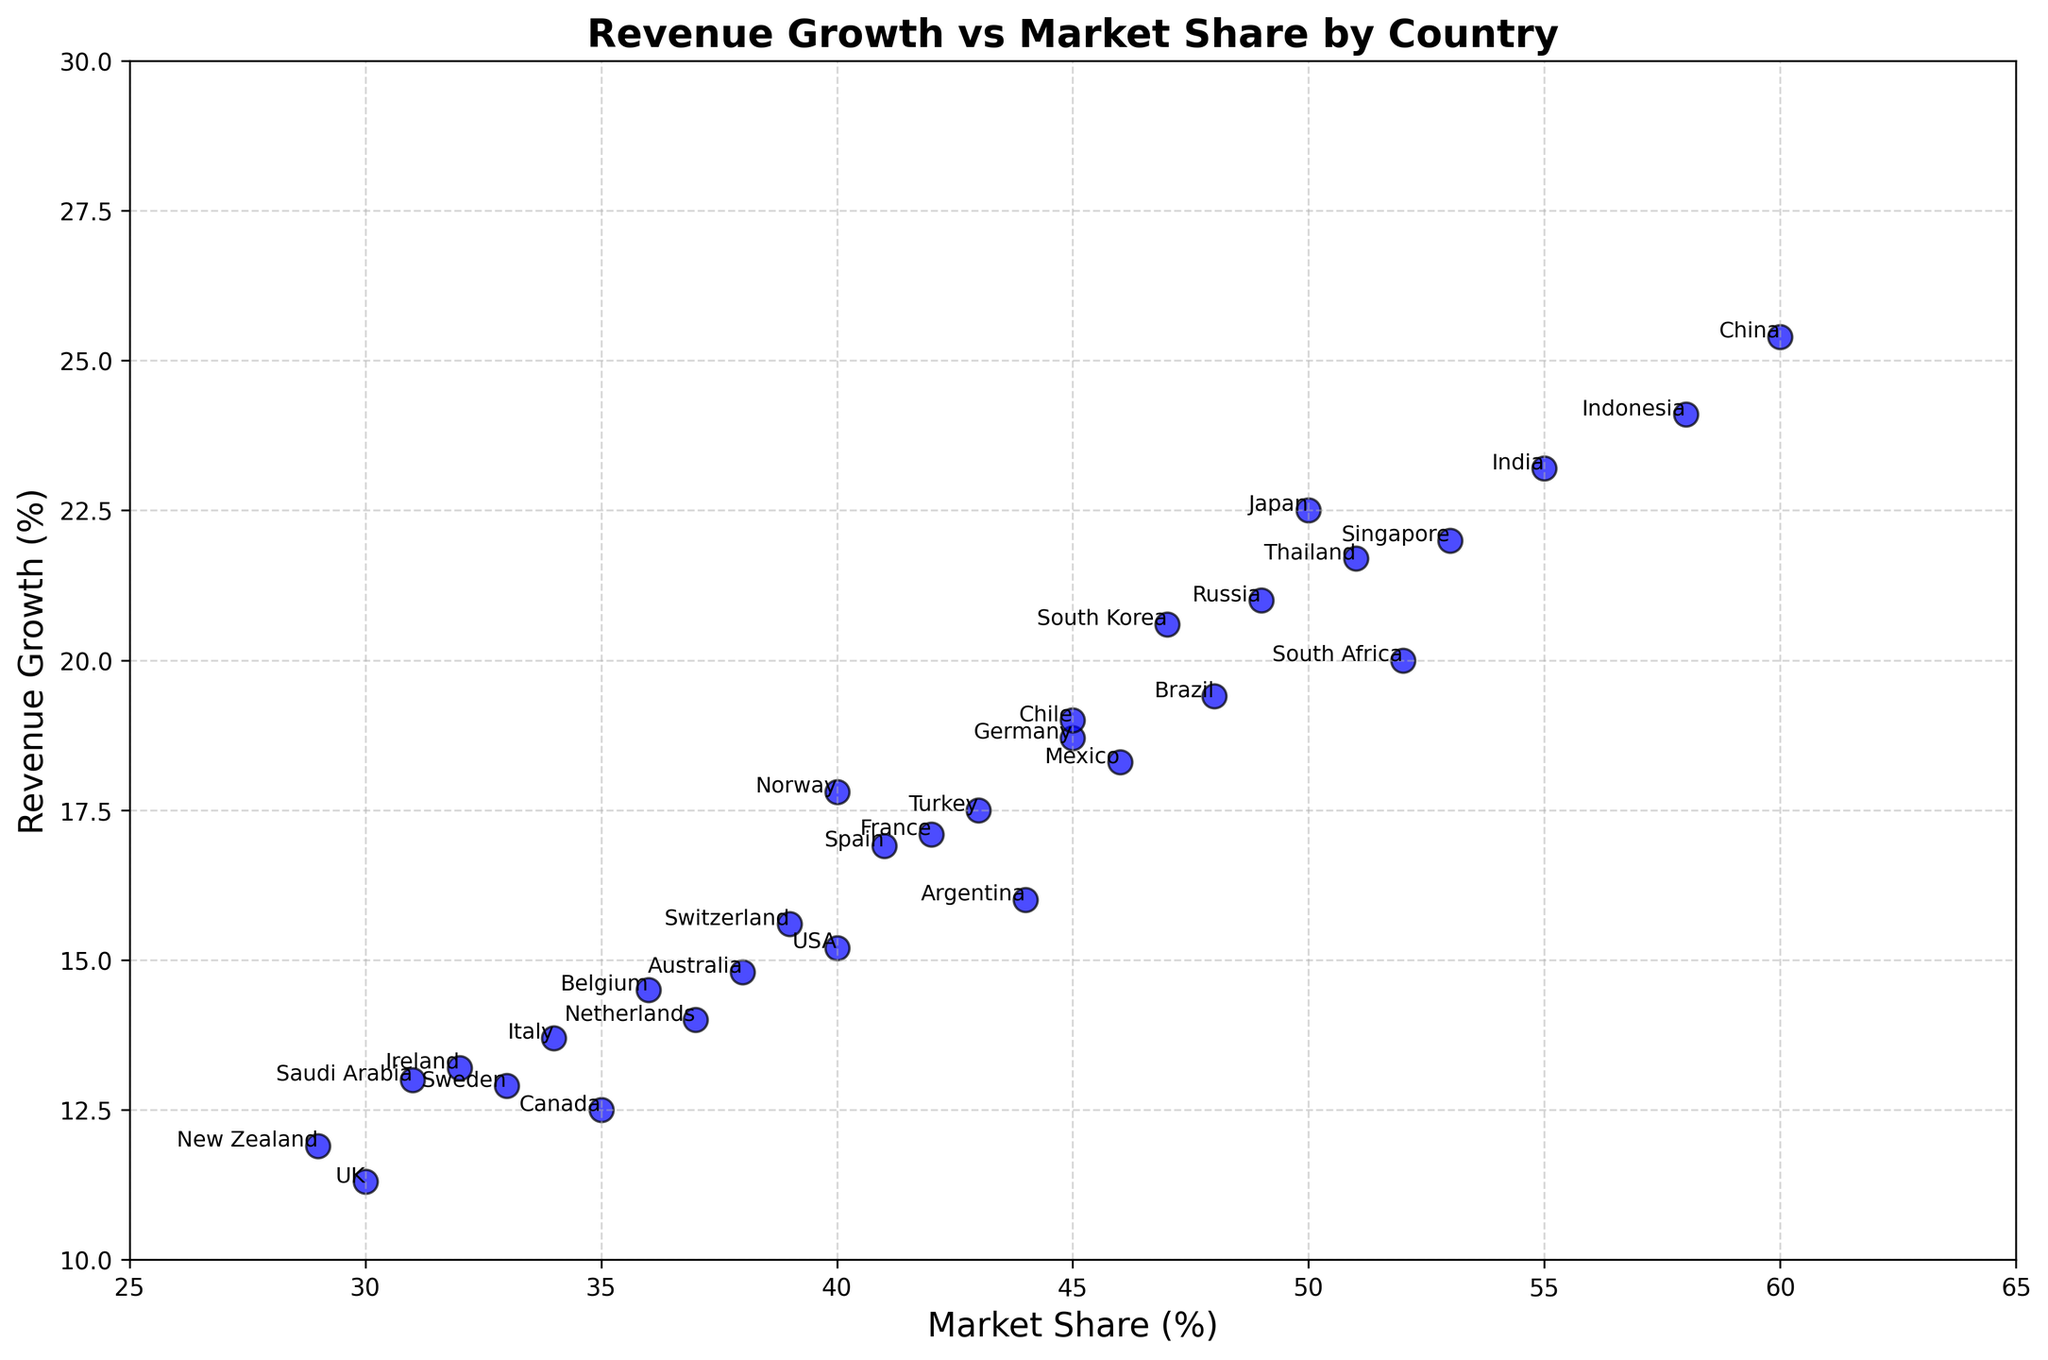What are the countries with the highest and lowest market shares? The plot shows 'China' with a market share of 60%, which is the highest, and 'New Zealand' with a market share of 29%, the lowest.
Answer: China, New Zealand What is the average revenue growth of countries with a market share greater than 45%? Identify the countries with >45% market share (Japan, South Korea, China, India, Brazil, Russia, South Africa, Singapore, Indonesia, Thailand). Their revenue growths are 22.5, 20.6, 25.4, 23.2, 19.4, 21.0, 20.0, 22.0, 24.1, 21.7 respectively. Sum these values and divide by the number of countries: (22.5 + 20.6 + 25.4 + 23.2 + 19.4 + 21.0 + 20.0 + 22.0 + 24.1 + 21.7) / 10 = 22.19
Answer: 22.19 Which country has the highest revenue growth, and what is that value? The scatter plot shows that China has the highest revenue growth at 25.4%.
Answer: China Which countries have both revenue growth above 20% and market share above 50%? From the plot, the countries that meet the criteria are China (25.4, 60), India (23.2, 55), South Africa (20.0, 52), Singapore (22.0, 53), Indonesia (24.1, 58), Thailand (21.7, 51).
Answer: China, India, South Africa, Singapore, Indonesia, Thailand Compare the market shares of Germany and France; which one is higher, and by how much? Germany has a market share of 45%, and France has 42%. The difference is 45 - 42 = 3%.
Answer: Germany, by 3% Is there a visible pattern between market share and revenue growth based on the plot? As the scatter plot suggests, there is a visible positive correlation—the higher the market share, the higher the revenue growth tends to be.
Answer: Positive correlation Which country is closer in revenue growth to the average growth of all countries? Compute average of all countries' revenue growth: (15.2 + 12.5 + 18.7 + 11.3 + 17.1 + 22.5 + 20.6 + 25.4 + 23.2 + ... + 13.2 + 11.9 + 17.8 + 14.5 + 19.0) / 30 = 17.64. Argentina, with revenue growth of 16.0, is closest.
Answer: Argentina What is the range of market share values in the plot? The plot shows the highest market share is 60% (China) and the lowest is 29% (New Zealand). The range is 60 - 29 = 31%.
Answer: 31% Compare the revenue growth of Japan and South Korea. Which country has a higher revenue growth and by how much? Japan's revenue growth is 22.5%, and South Korea's is 20.6%. The difference is 22.5 - 20.6 = 1.9%.
Answer: Japan, by 1.9% 